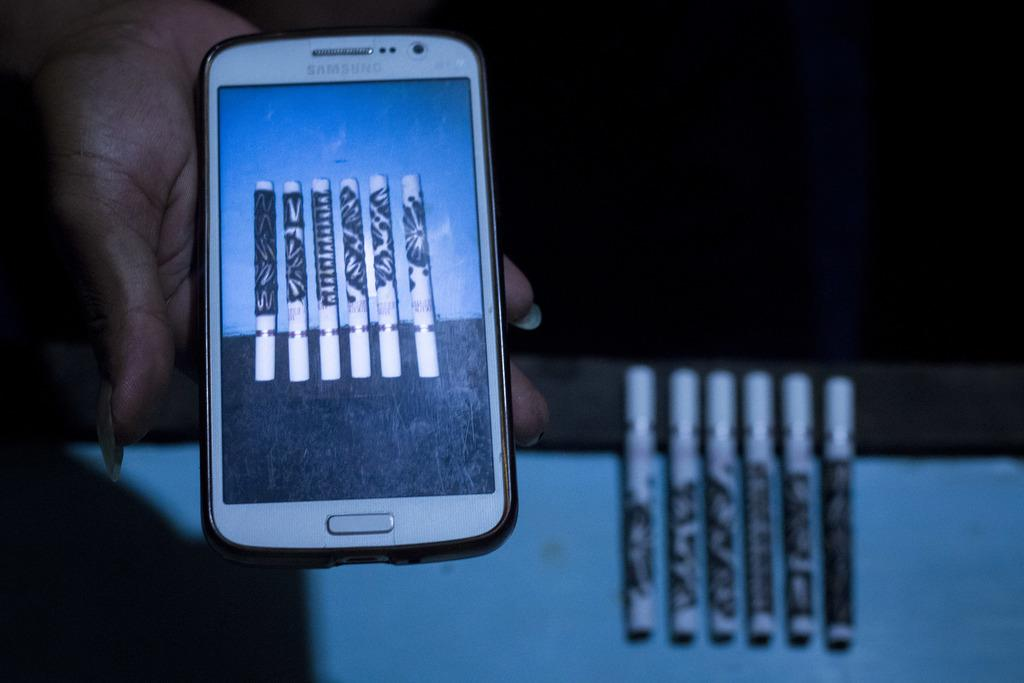<image>
Summarize the visual content of the image. A samsung smartphone shows 6 cigarette shaped vapers while the vapers are displayed behind it. 